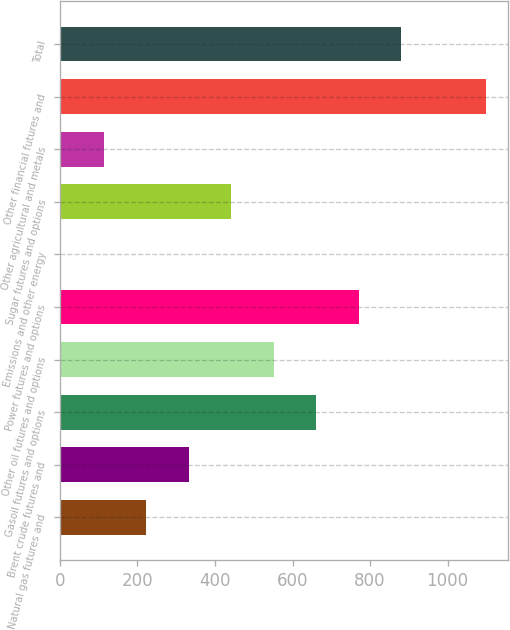Convert chart to OTSL. <chart><loc_0><loc_0><loc_500><loc_500><bar_chart><fcel>Natural gas futures and<fcel>Brent crude futures and<fcel>Gasoil futures and options<fcel>Other oil futures and options<fcel>Power futures and options<fcel>Emissions and other energy<fcel>Sugar futures and options<fcel>Other agricultural and metals<fcel>Other financial futures and<fcel>Total<nl><fcel>222.4<fcel>332.1<fcel>661.2<fcel>551.5<fcel>770.9<fcel>3<fcel>441.8<fcel>112.7<fcel>1100<fcel>880.6<nl></chart> 